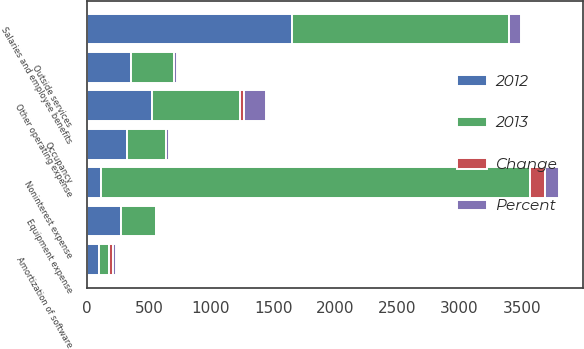Convert chart. <chart><loc_0><loc_0><loc_500><loc_500><stacked_bar_chart><ecel><fcel>Salaries and employee benefits<fcel>Outside services<fcel>Occupancy<fcel>Equipment expense<fcel>Amortization of software<fcel>Other operating expense<fcel>Noninterest expense<nl><fcel>2012<fcel>1652<fcel>360<fcel>327<fcel>275<fcel>102<fcel>528<fcel>112<nl><fcel>2013<fcel>1743<fcel>339<fcel>310<fcel>279<fcel>77<fcel>709<fcel>3457<nl><fcel>Percent<fcel>91<fcel>21<fcel>17<fcel>4<fcel>25<fcel>181<fcel>112<nl><fcel>Change<fcel>5<fcel>6<fcel>5<fcel>1<fcel>32<fcel>26<fcel>122<nl></chart> 